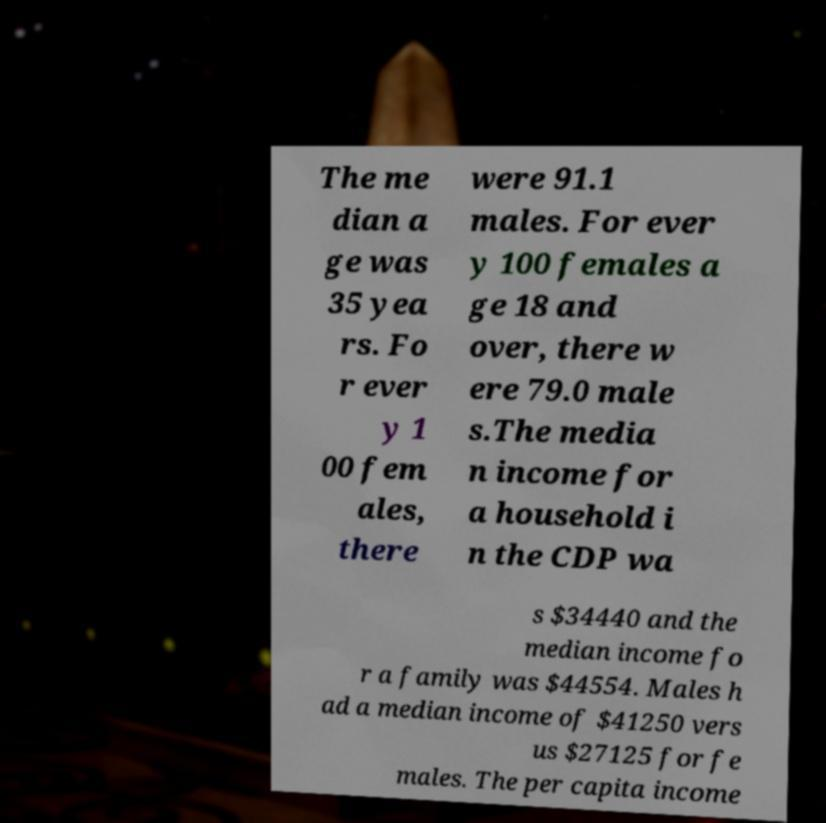Please identify and transcribe the text found in this image. The me dian a ge was 35 yea rs. Fo r ever y 1 00 fem ales, there were 91.1 males. For ever y 100 females a ge 18 and over, there w ere 79.0 male s.The media n income for a household i n the CDP wa s $34440 and the median income fo r a family was $44554. Males h ad a median income of $41250 vers us $27125 for fe males. The per capita income 